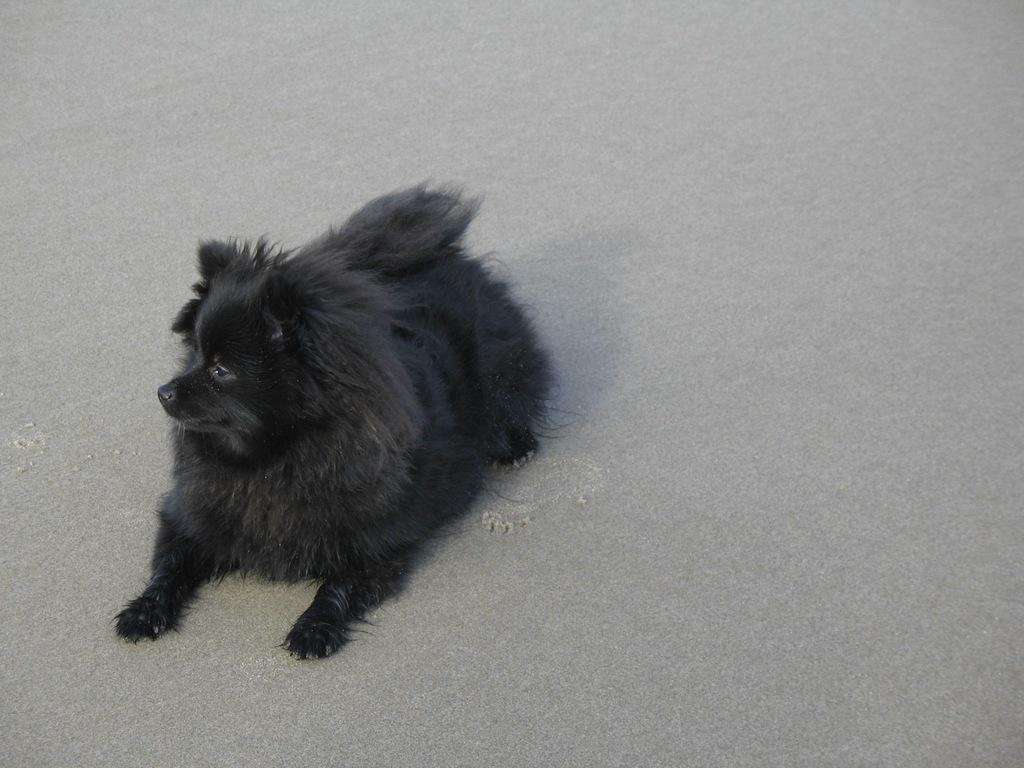What type of animal is in the image? There is a black dog in the image. What is the dog doing in the image? The dog is sitting on the ground. What type of juice is the dog drinking in the image? There is no juice present in the image; the dog is sitting on the ground. 